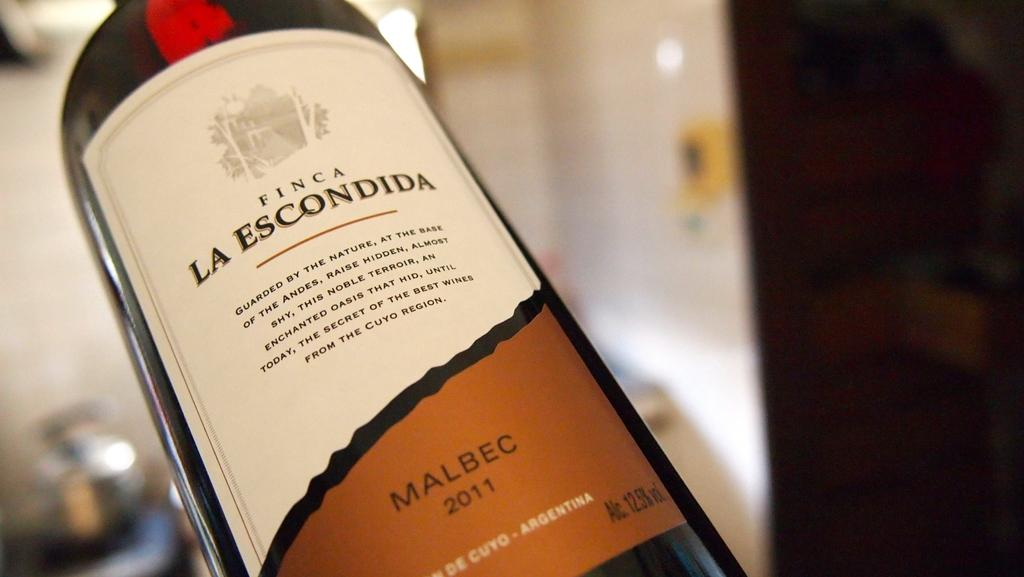<image>
Describe the image concisely. A bottle of Finca La Escondida Malbec is from 2011. 